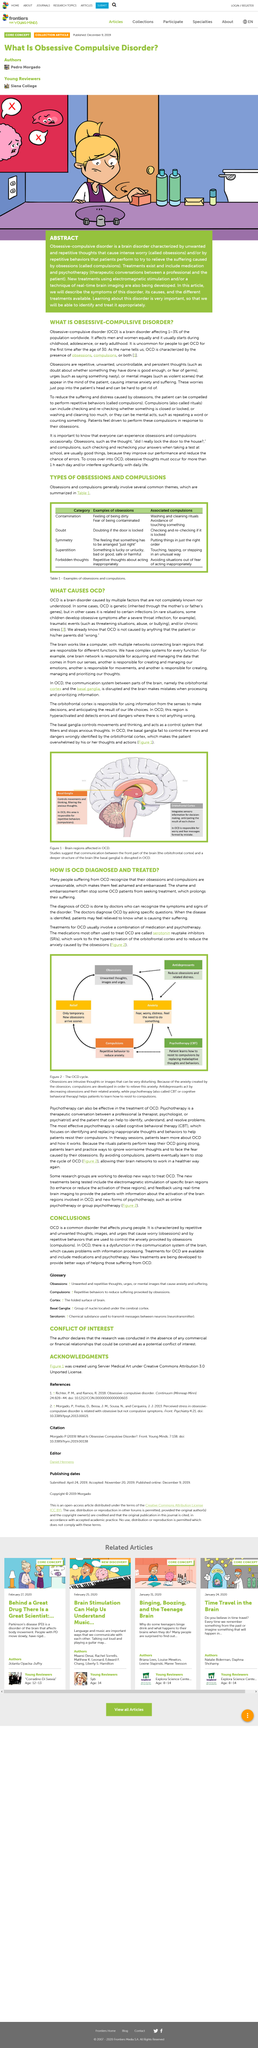Outline some significant characteristics in this image. OCD (Obsessive-Compulsive Disorder) can be inherited genetically. Obsessive-compulsive disorder typically begins during childhood, adolescence, or early adulthood. In this article, the term "Serotonin Reuptake Inhibitors" is defined as "SRIs". Obsessive-compulsive disorder (OCD) is a neurological condition that is caused by complex interactions between multiple genetic and environmental factors that are not fully understood. It is common to use Serotonin Reuptake Inhibitors to treat Obsessive Compulsive Disorder (OCD). 